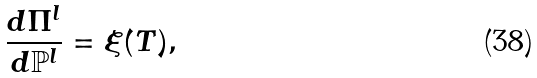Convert formula to latex. <formula><loc_0><loc_0><loc_500><loc_500>\frac { d \Pi ^ { l } } { d \mathbb { P } ^ { l } } = \xi ( T ) ,</formula> 